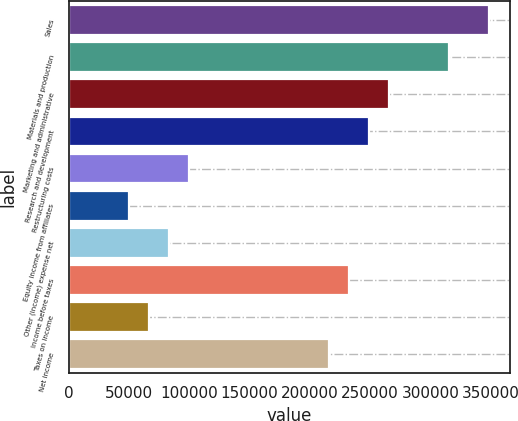Convert chart. <chart><loc_0><loc_0><loc_500><loc_500><bar_chart><fcel>Sales<fcel>Materials and production<fcel>Marketing and administrative<fcel>Research and development<fcel>Restructuring costs<fcel>Equity income from affiliates<fcel>Other (income) expense net<fcel>Income before taxes<fcel>Taxes on income<fcel>Net income<nl><fcel>348808<fcel>315588<fcel>265759<fcel>249149<fcel>99660.8<fcel>49831.4<fcel>83051<fcel>232539<fcel>66441.2<fcel>215929<nl></chart> 